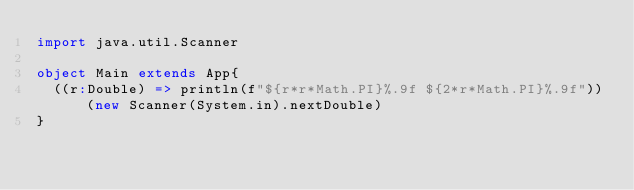Convert code to text. <code><loc_0><loc_0><loc_500><loc_500><_Scala_>import java.util.Scanner

object Main extends App{
  ((r:Double) => println(f"${r*r*Math.PI}%.9f ${2*r*Math.PI}%.9f"))(new Scanner(System.in).nextDouble)
}</code> 